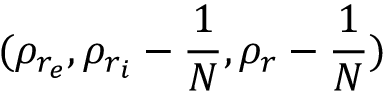Convert formula to latex. <formula><loc_0><loc_0><loc_500><loc_500>( \rho _ { r _ { e } } , \rho _ { r _ { i } } - \frac { 1 } { N } , \rho _ { r } - \frac { 1 } { N } )</formula> 